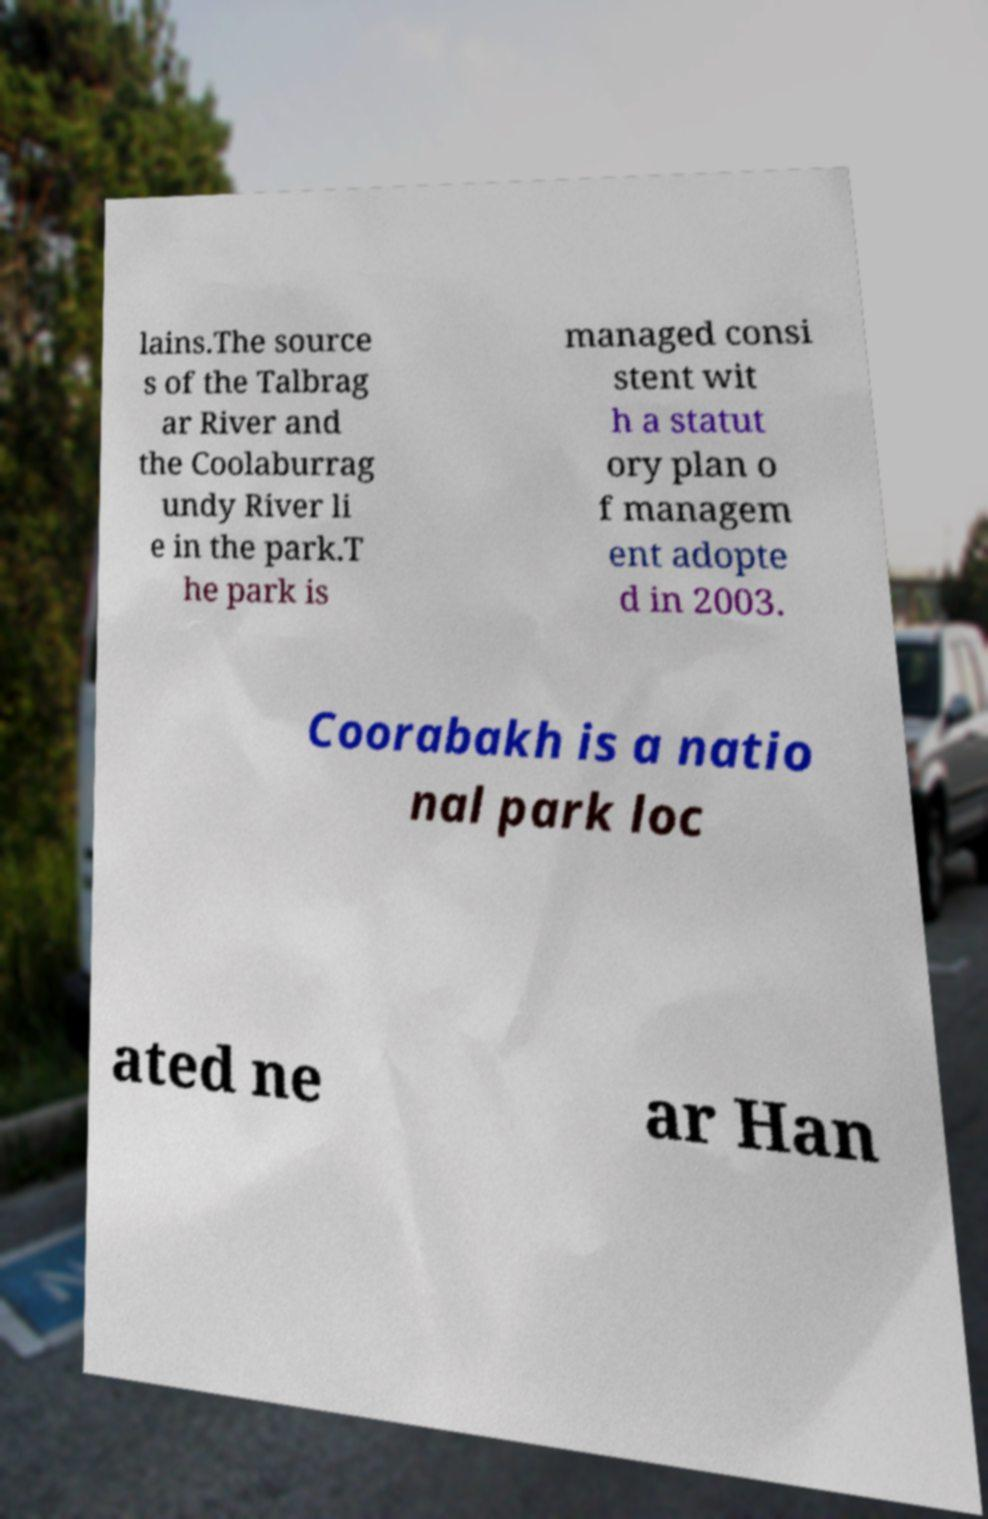I need the written content from this picture converted into text. Can you do that? lains.The source s of the Talbrag ar River and the Coolaburrag undy River li e in the park.T he park is managed consi stent wit h a statut ory plan o f managem ent adopte d in 2003. Coorabakh is a natio nal park loc ated ne ar Han 